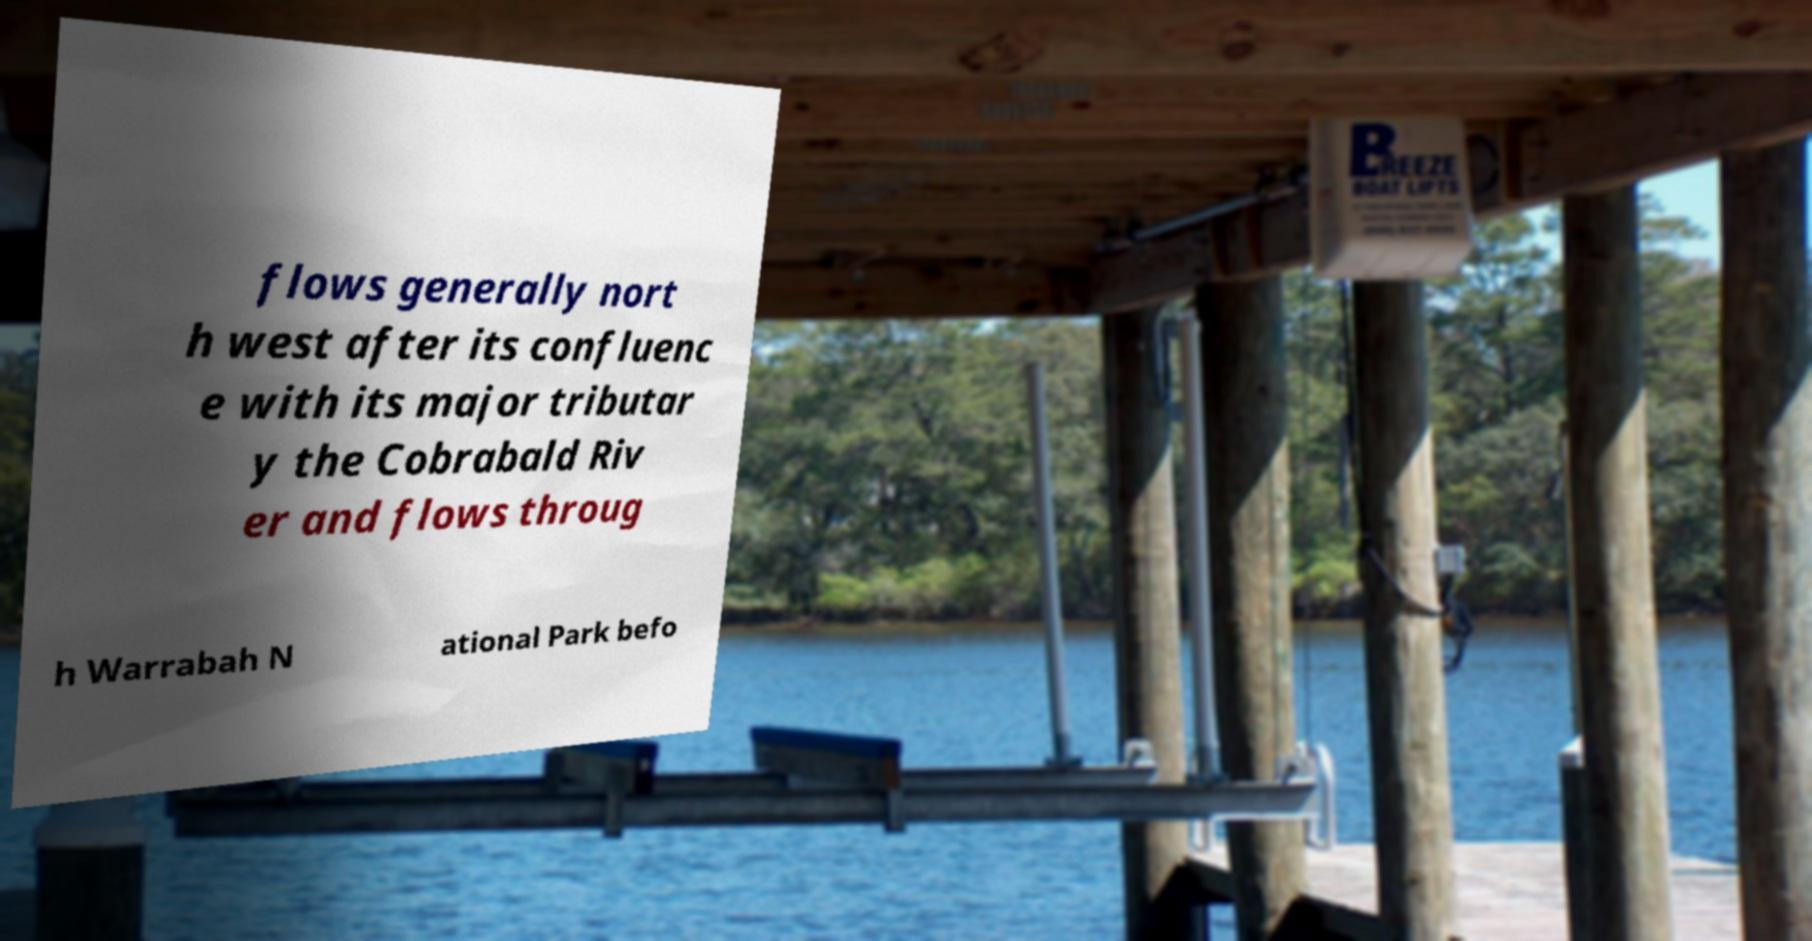There's text embedded in this image that I need extracted. Can you transcribe it verbatim? flows generally nort h west after its confluenc e with its major tributar y the Cobrabald Riv er and flows throug h Warrabah N ational Park befo 